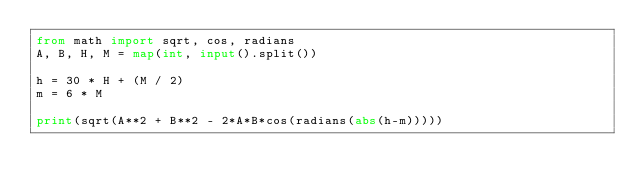<code> <loc_0><loc_0><loc_500><loc_500><_Python_>from math import sqrt, cos, radians
A, B, H, M = map(int, input().split())

h = 30 * H + (M / 2)
m = 6 * M

print(sqrt(A**2 + B**2 - 2*A*B*cos(radians(abs(h-m)))))
</code> 